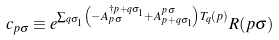<formula> <loc_0><loc_0><loc_500><loc_500>c _ { { p } \sigma } \equiv e ^ { \sum _ { { q } \sigma _ { 1 } } \left ( - A _ { { p } \sigma } ^ { \dagger { p } + { q } \sigma _ { 1 } } + A _ { { p } + { q } \sigma _ { 1 } } ^ { { p } \sigma } \right ) T _ { q } ( { p } ) } R ( { p } \sigma )</formula> 